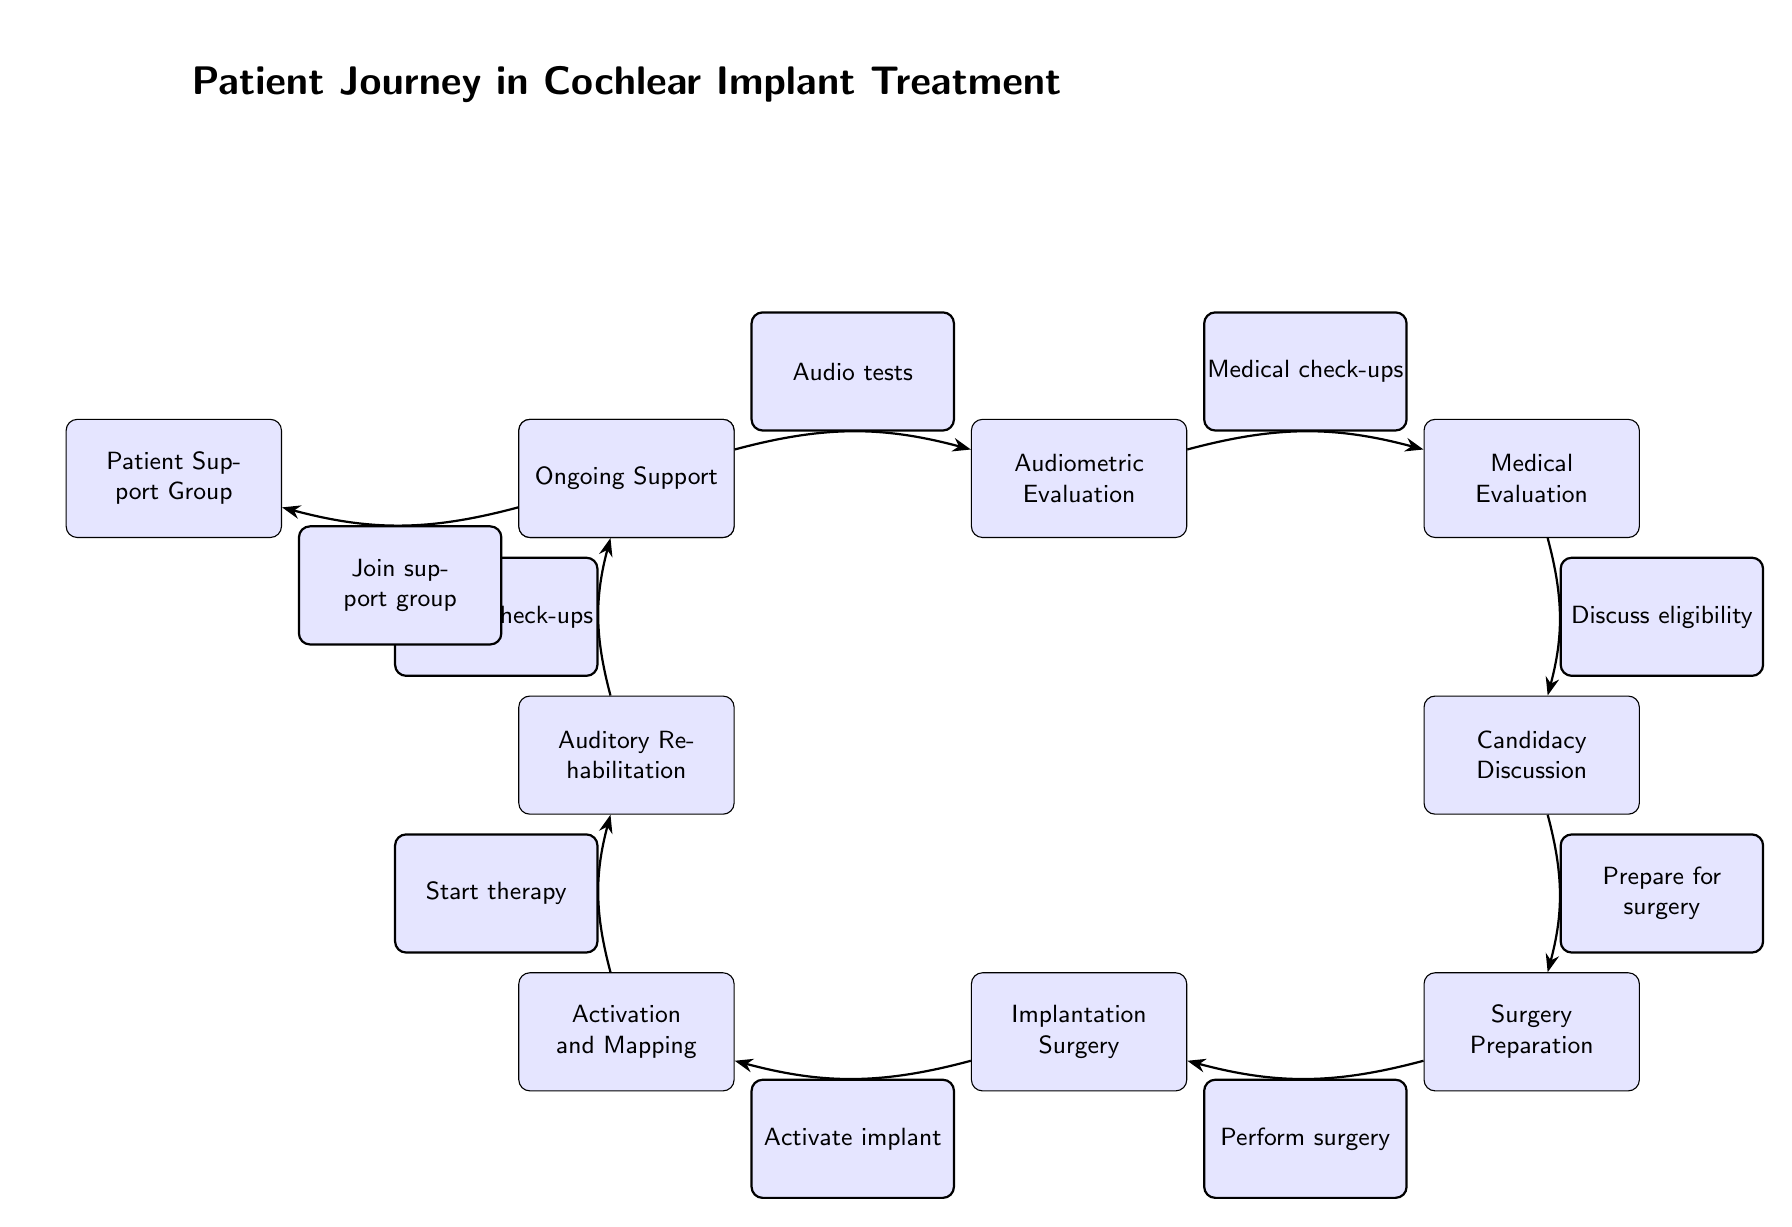What is the first step in the patient journey? The diagram shows that the first step is the "Initial Consultation." It is prominently placed at the beginning of the flow.
Answer: Initial Consultation How many main steps are depicted in the journey? By counting each unique node in the diagram, we find there are ten main steps from "Initial Consultation" to "Patient Support Group."
Answer: 10 What step follows the "Medical Evaluation"? The diagram shows that after "Medical Evaluation," the next step is "Candidacy Discussion." This is indicated by the directed edge leading from "Medical Evaluation" to "Candidacy Discussion."
Answer: Candidacy Discussion What is the last step in the patient journey according to the diagram? The last node in the flow signifies "Patient Support Group," which is reached after progressing through all prior steps.
Answer: Patient Support Group What action is associated with the "Activation and Mapping" step? The edge coming from "Activation and Mapping" points to "Auditory Rehabilitation" indicating that after activation, the next action relates to starting therapy.
Answer: Start therapy Which step involves preparing for surgery? "Surgery Preparation" is the specific step that focuses on preparing for the surgery. It is shown as a direct step following "Candidacy Discussion."
Answer: Surgery Preparation What kind of support is provided after the rehabilitation? "Ongoing Support" follows "Auditory Rehabilitation" indicating continuous assistance after the therapy is initiated.
Answer: Ongoing Support How does a patient connect with a support group? After "Ongoing Support," patients are encouraged to "Join support group," demonstrating the transition to community involvement.
Answer: Join support group What prerequisite must be completed before performing surgery? "Surgery Preparation" must be completed prior to the actual "Implantation Surgery," showcasing the necessary preparations required.
Answer: Prepare for surgery 